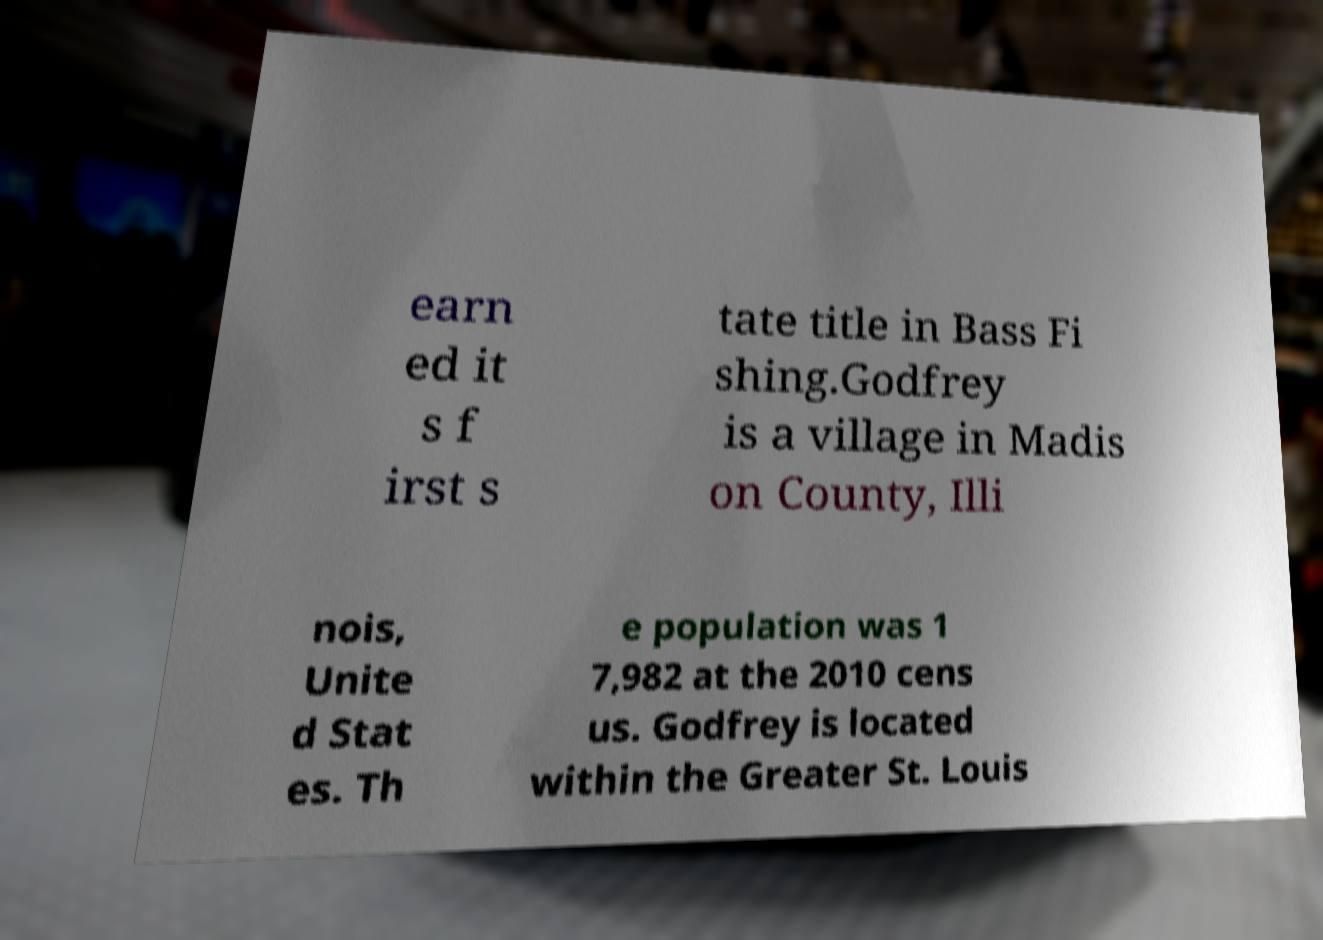Can you read and provide the text displayed in the image?This photo seems to have some interesting text. Can you extract and type it out for me? earn ed it s f irst s tate title in Bass Fi shing.Godfrey is a village in Madis on County, Illi nois, Unite d Stat es. Th e population was 1 7,982 at the 2010 cens us. Godfrey is located within the Greater St. Louis 